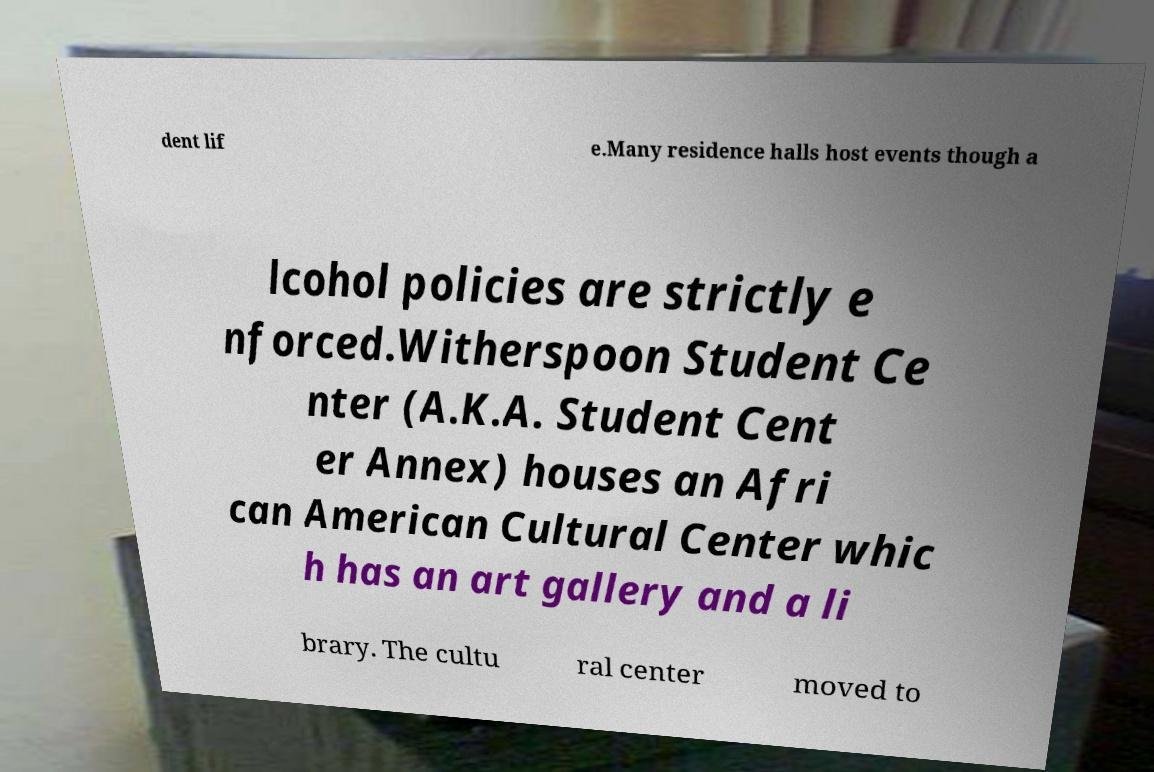Could you assist in decoding the text presented in this image and type it out clearly? dent lif e.Many residence halls host events though a lcohol policies are strictly e nforced.Witherspoon Student Ce nter (A.K.A. Student Cent er Annex) houses an Afri can American Cultural Center whic h has an art gallery and a li brary. The cultu ral center moved to 